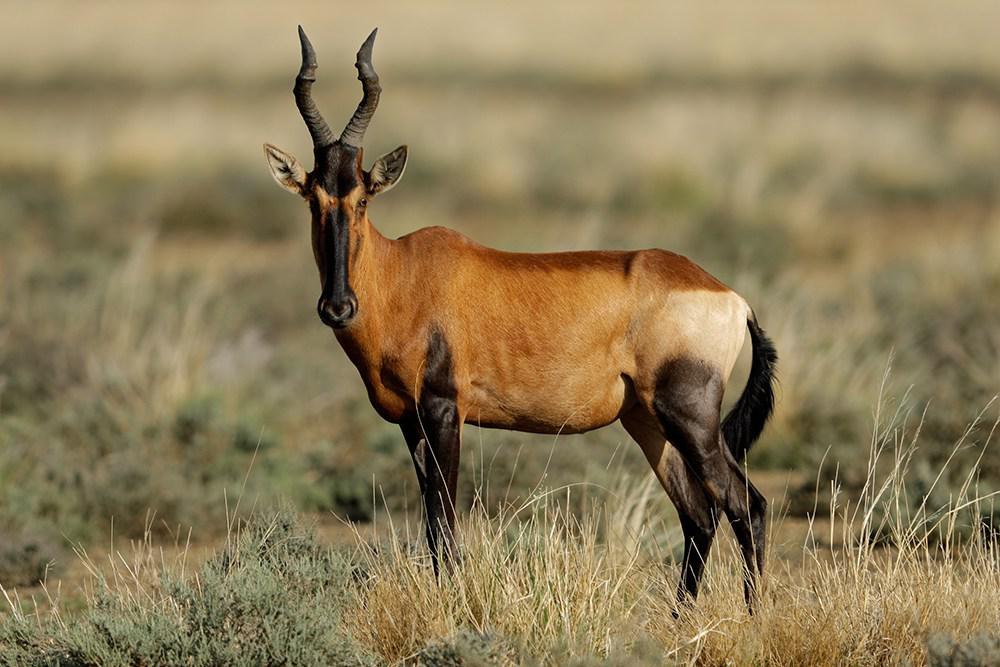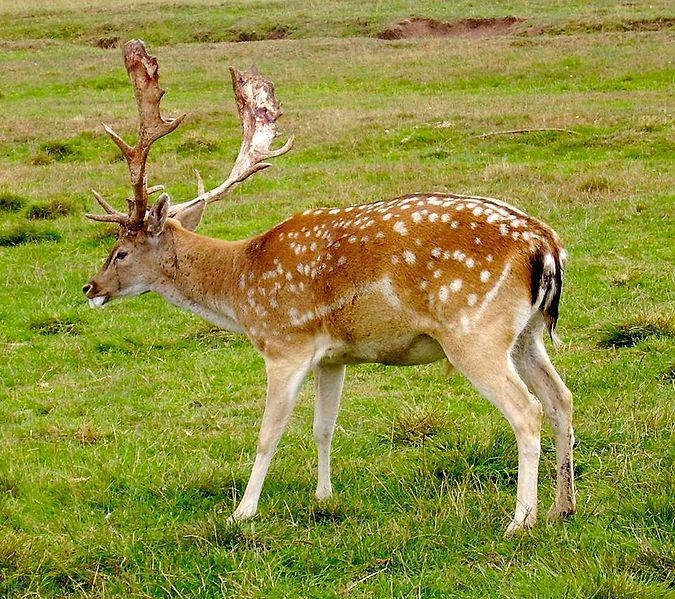The first image is the image on the left, the second image is the image on the right. For the images shown, is this caption "There are 3 animals." true? Answer yes or no. No. 